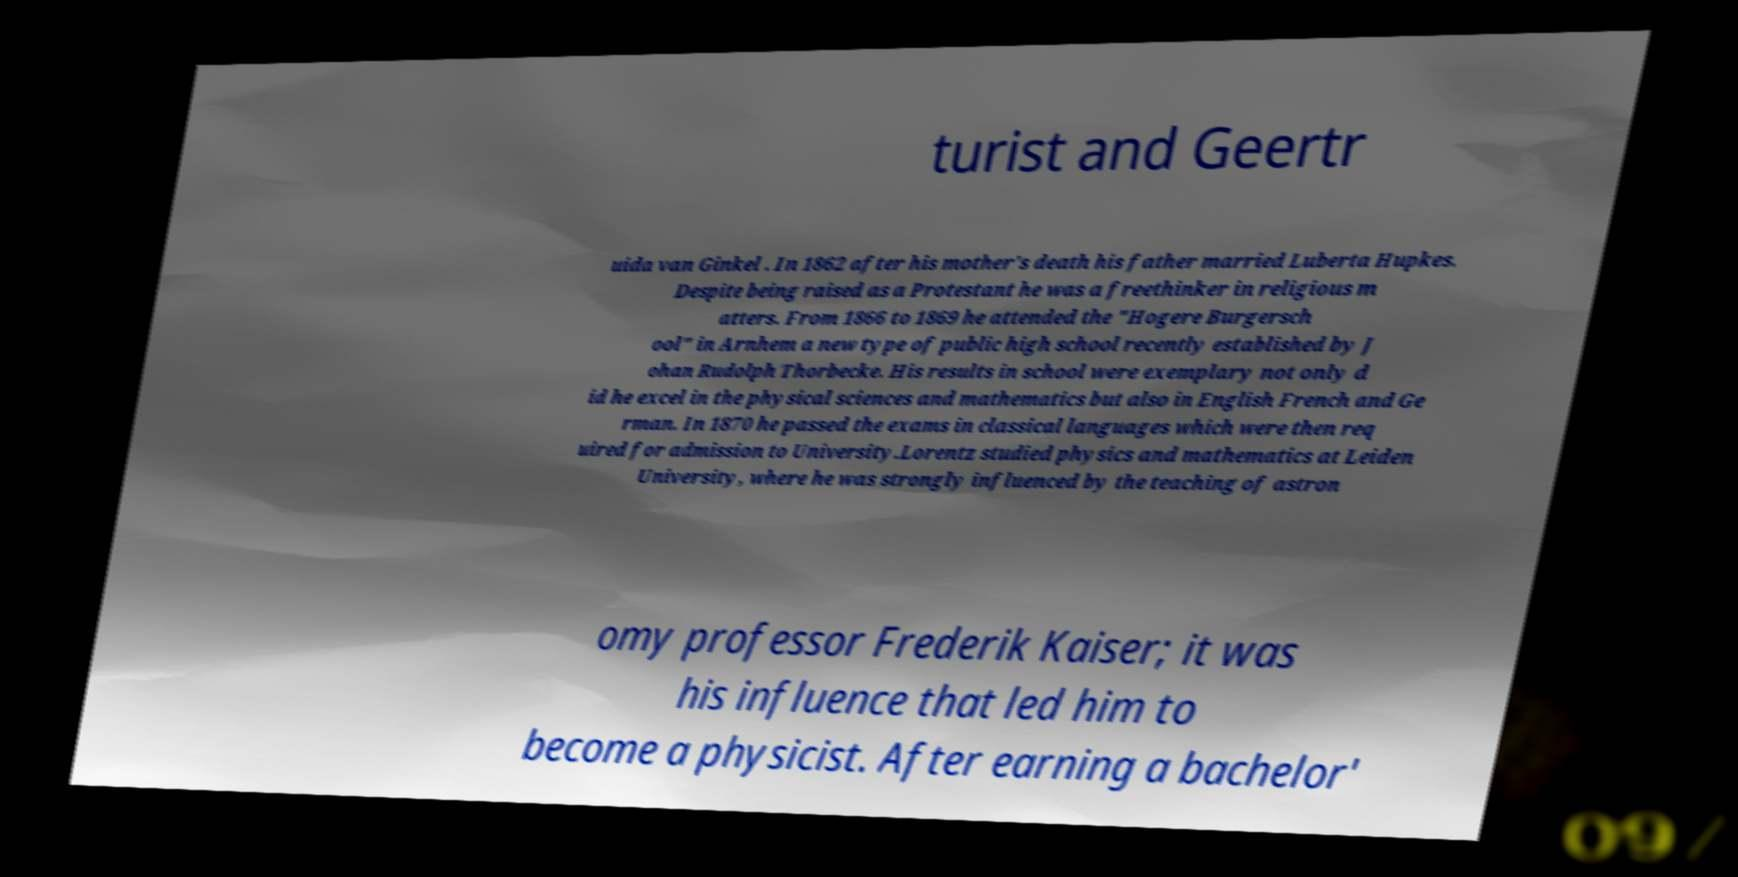Could you assist in decoding the text presented in this image and type it out clearly? turist and Geertr uida van Ginkel . In 1862 after his mother's death his father married Luberta Hupkes. Despite being raised as a Protestant he was a freethinker in religious m atters. From 1866 to 1869 he attended the "Hogere Burgersch ool" in Arnhem a new type of public high school recently established by J ohan Rudolph Thorbecke. His results in school were exemplary not only d id he excel in the physical sciences and mathematics but also in English French and Ge rman. In 1870 he passed the exams in classical languages which were then req uired for admission to University.Lorentz studied physics and mathematics at Leiden University, where he was strongly influenced by the teaching of astron omy professor Frederik Kaiser; it was his influence that led him to become a physicist. After earning a bachelor' 